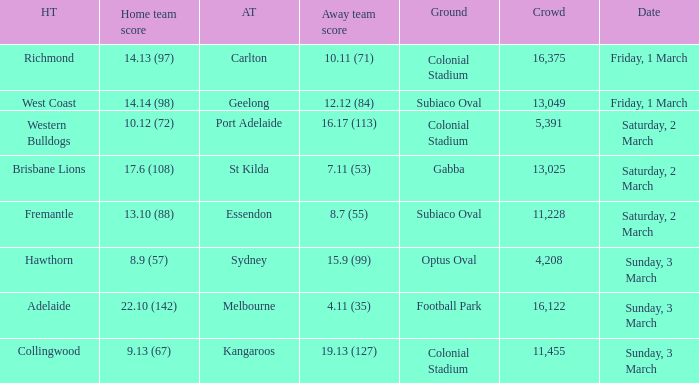What was the ground for away team sydney? Optus Oval. 